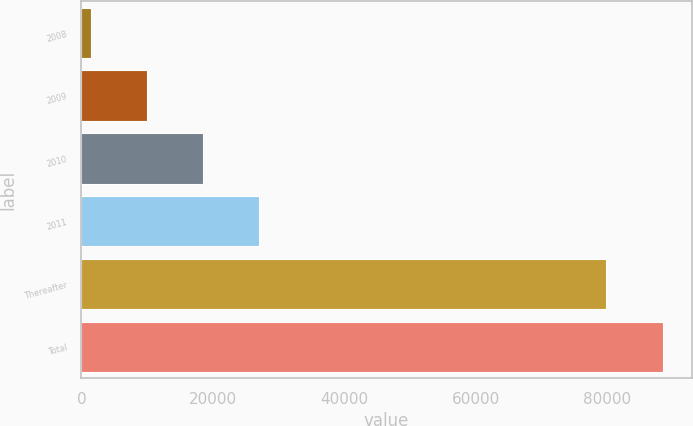<chart> <loc_0><loc_0><loc_500><loc_500><bar_chart><fcel>2008<fcel>2009<fcel>2010<fcel>2011<fcel>Thereafter<fcel>Total<nl><fcel>1396<fcel>9944.9<fcel>18493.8<fcel>27042.7<fcel>79837<fcel>88385.9<nl></chart> 